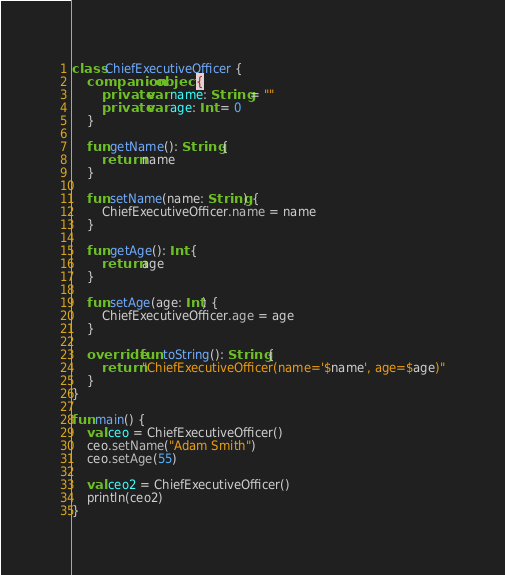Convert code to text. <code><loc_0><loc_0><loc_500><loc_500><_Kotlin_>
class ChiefExecutiveOfficer {
    companion object {
        private var name: String = ""
        private var age: Int = 0
    }

    fun getName(): String {
        return name
    }

    fun setName(name: String) {
        ChiefExecutiveOfficer.name = name
    }

    fun getAge(): Int {
        return age
    }

    fun setAge(age: Int) {
        ChiefExecutiveOfficer.age = age
    }

    override fun toString(): String {
        return "ChiefExecutiveOfficer(name='$name', age=$age)"
    }
}

fun main() {
    val ceo = ChiefExecutiveOfficer()
    ceo.setName("Adam Smith")
    ceo.setAge(55)

    val ceo2 = ChiefExecutiveOfficer()
    println(ceo2)
}
</code> 